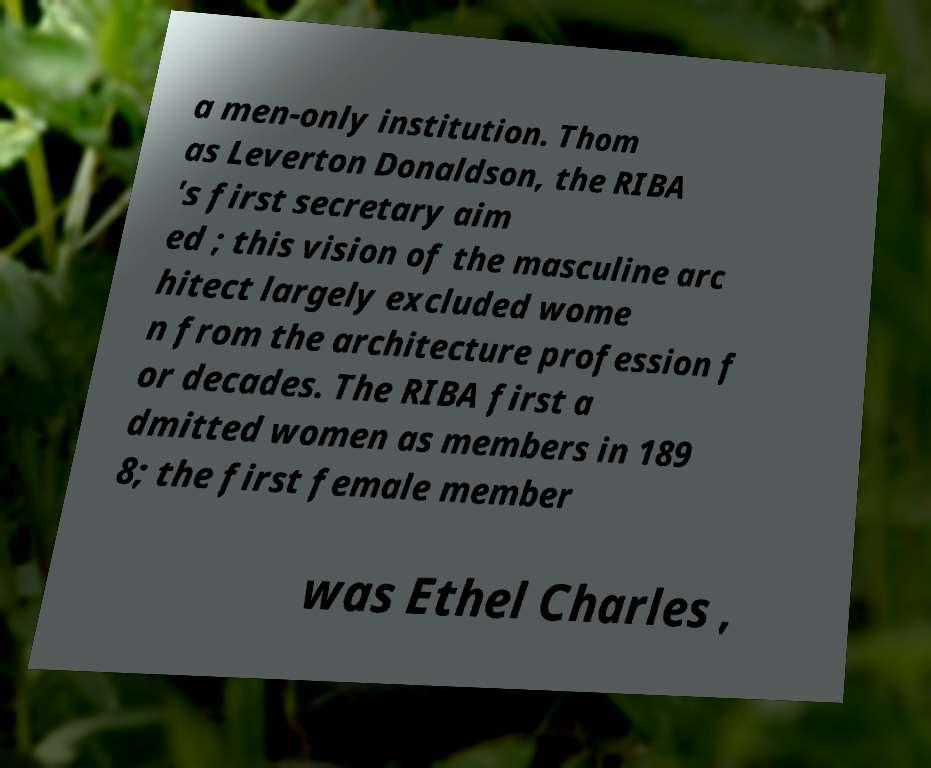I need the written content from this picture converted into text. Can you do that? a men-only institution. Thom as Leverton Donaldson, the RIBA 's first secretary aim ed ; this vision of the masculine arc hitect largely excluded wome n from the architecture profession f or decades. The RIBA first a dmitted women as members in 189 8; the first female member was Ethel Charles , 